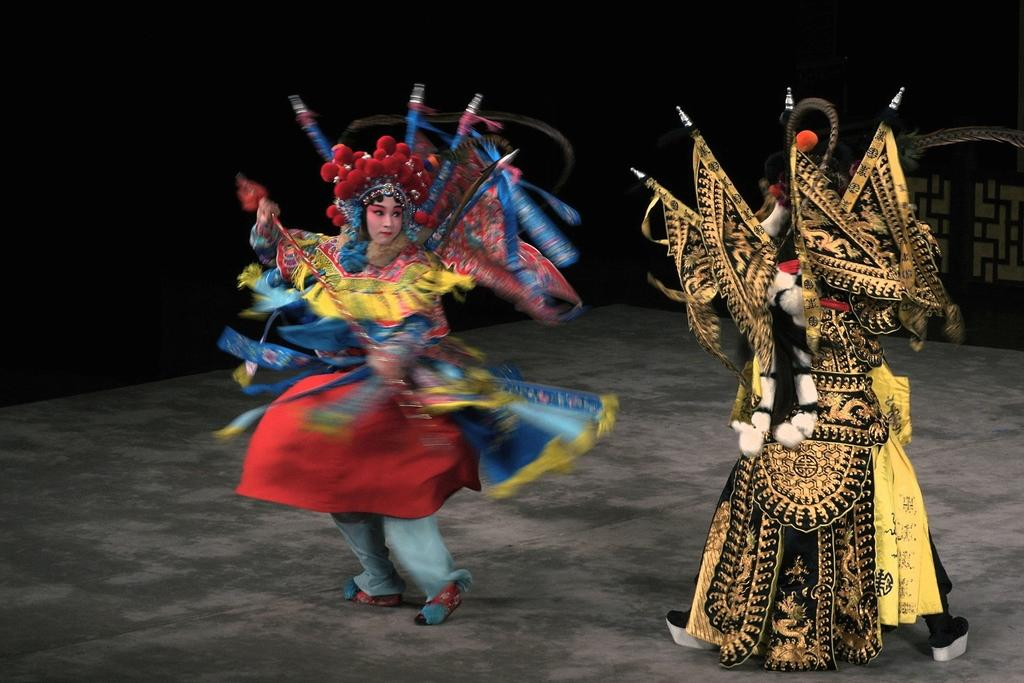Who or what can be seen in the image? There are people in the image. What are the people wearing? The people are wearing costumes. What are the people doing in the image? The people are dancing on the floor. What type of coil is being used by the people in the image? There is no coil present in the image; the people are dancing while wearing costumes. What kind of machine is depicted in the image? There is no machine present in the image; it features people dancing in costumes. 